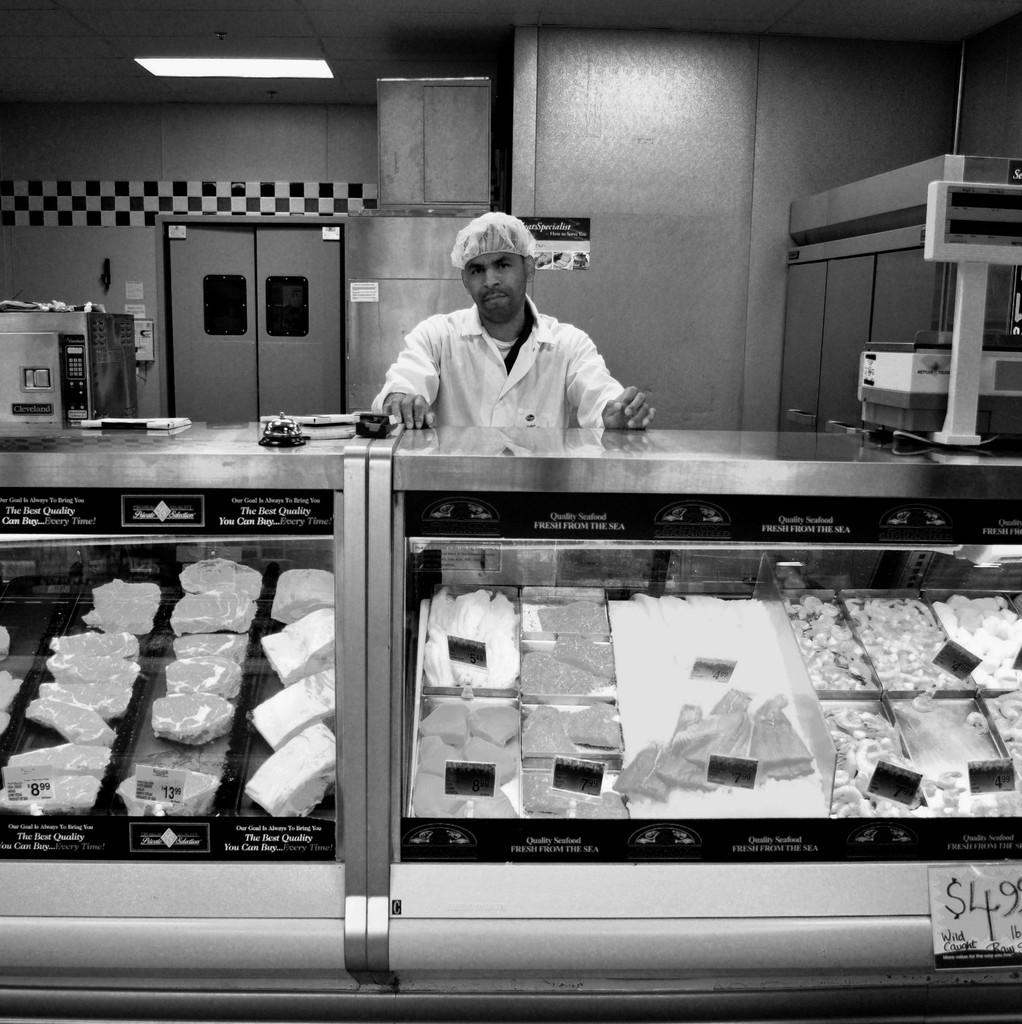<image>
Create a compact narrative representing the image presented. Man standing behind a meat fridge with the price tag of $4.99 on the front. 